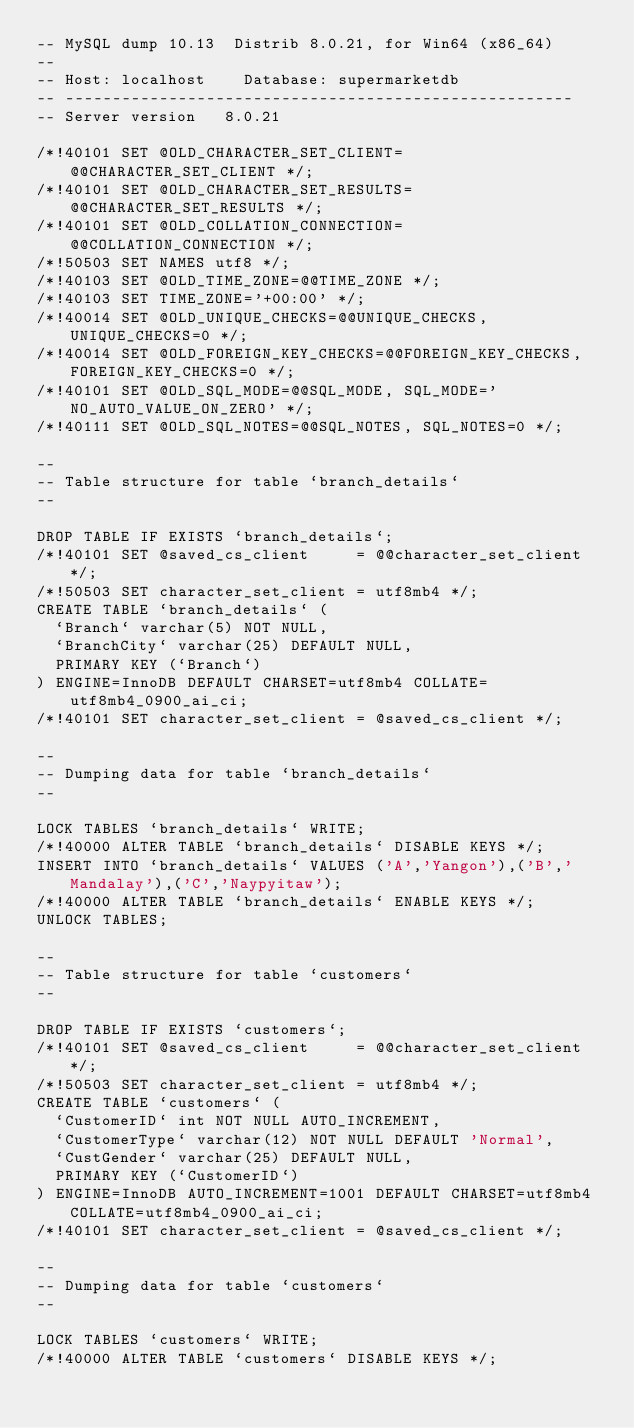<code> <loc_0><loc_0><loc_500><loc_500><_SQL_>-- MySQL dump 10.13  Distrib 8.0.21, for Win64 (x86_64)
--
-- Host: localhost    Database: supermarketdb
-- ------------------------------------------------------
-- Server version	8.0.21

/*!40101 SET @OLD_CHARACTER_SET_CLIENT=@@CHARACTER_SET_CLIENT */;
/*!40101 SET @OLD_CHARACTER_SET_RESULTS=@@CHARACTER_SET_RESULTS */;
/*!40101 SET @OLD_COLLATION_CONNECTION=@@COLLATION_CONNECTION */;
/*!50503 SET NAMES utf8 */;
/*!40103 SET @OLD_TIME_ZONE=@@TIME_ZONE */;
/*!40103 SET TIME_ZONE='+00:00' */;
/*!40014 SET @OLD_UNIQUE_CHECKS=@@UNIQUE_CHECKS, UNIQUE_CHECKS=0 */;
/*!40014 SET @OLD_FOREIGN_KEY_CHECKS=@@FOREIGN_KEY_CHECKS, FOREIGN_KEY_CHECKS=0 */;
/*!40101 SET @OLD_SQL_MODE=@@SQL_MODE, SQL_MODE='NO_AUTO_VALUE_ON_ZERO' */;
/*!40111 SET @OLD_SQL_NOTES=@@SQL_NOTES, SQL_NOTES=0 */;

--
-- Table structure for table `branch_details`
--

DROP TABLE IF EXISTS `branch_details`;
/*!40101 SET @saved_cs_client     = @@character_set_client */;
/*!50503 SET character_set_client = utf8mb4 */;
CREATE TABLE `branch_details` (
  `Branch` varchar(5) NOT NULL,
  `BranchCity` varchar(25) DEFAULT NULL,
  PRIMARY KEY (`Branch`)
) ENGINE=InnoDB DEFAULT CHARSET=utf8mb4 COLLATE=utf8mb4_0900_ai_ci;
/*!40101 SET character_set_client = @saved_cs_client */;

--
-- Dumping data for table `branch_details`
--

LOCK TABLES `branch_details` WRITE;
/*!40000 ALTER TABLE `branch_details` DISABLE KEYS */;
INSERT INTO `branch_details` VALUES ('A','Yangon'),('B','Mandalay'),('C','Naypyitaw');
/*!40000 ALTER TABLE `branch_details` ENABLE KEYS */;
UNLOCK TABLES;

--
-- Table structure for table `customers`
--

DROP TABLE IF EXISTS `customers`;
/*!40101 SET @saved_cs_client     = @@character_set_client */;
/*!50503 SET character_set_client = utf8mb4 */;
CREATE TABLE `customers` (
  `CustomerID` int NOT NULL AUTO_INCREMENT,
  `CustomerType` varchar(12) NOT NULL DEFAULT 'Normal',
  `CustGender` varchar(25) DEFAULT NULL,
  PRIMARY KEY (`CustomerID`)
) ENGINE=InnoDB AUTO_INCREMENT=1001 DEFAULT CHARSET=utf8mb4 COLLATE=utf8mb4_0900_ai_ci;
/*!40101 SET character_set_client = @saved_cs_client */;

--
-- Dumping data for table `customers`
--

LOCK TABLES `customers` WRITE;
/*!40000 ALTER TABLE `customers` DISABLE KEYS */;</code> 